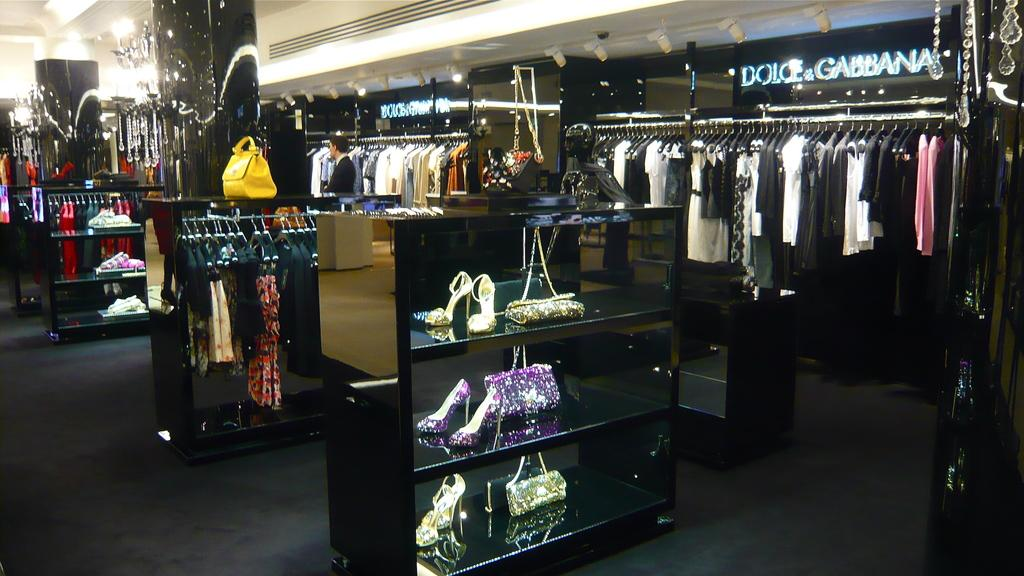<image>
Write a terse but informative summary of the picture. Retail store for Dolce & Gabanna selling shoes and purses in the front. 